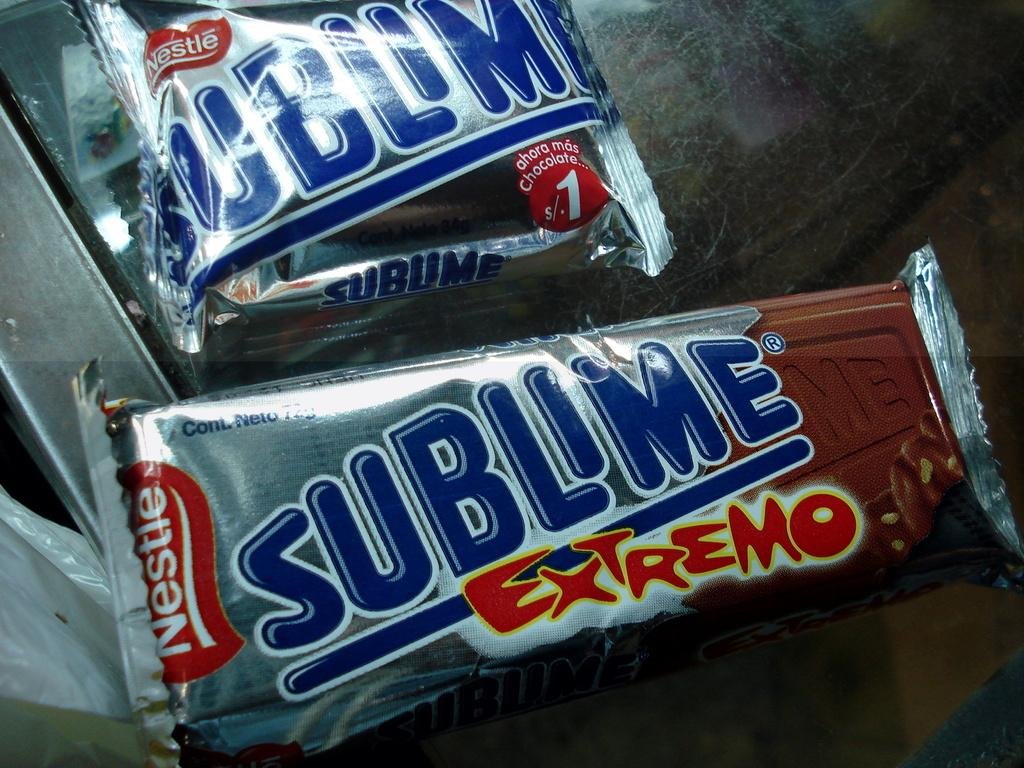<image>
Summarize the visual content of the image. A couple of Nestle ice cream treats promise extreme deliciousness. 